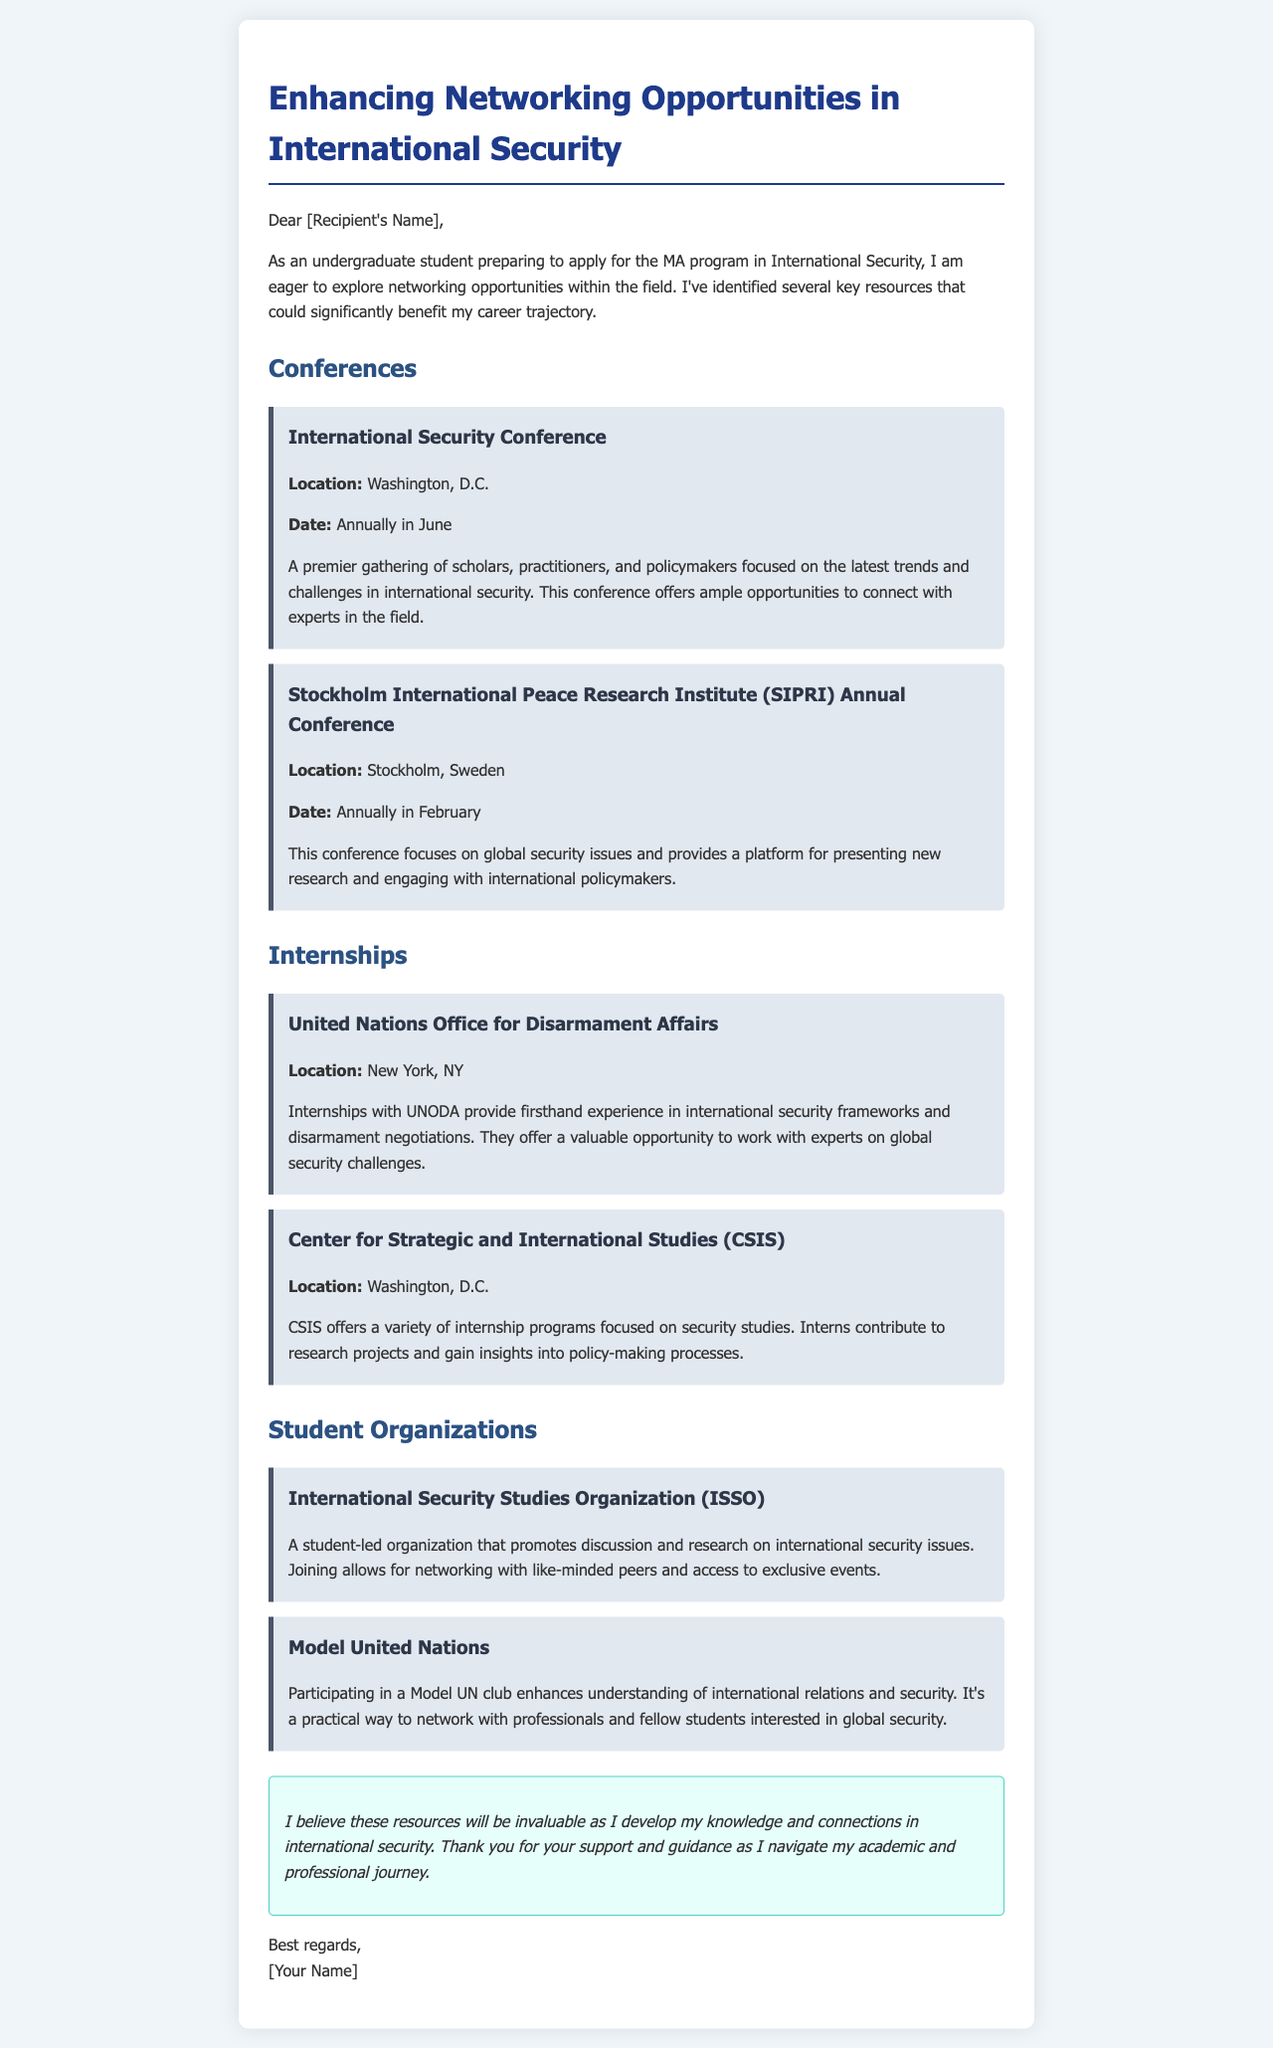what is the location of the International Security Conference? The location of the International Security Conference is mentioned in the document as Washington, D.C.
Answer: Washington, D.C what is the date of the SIPRI Annual Conference? The date for the SIPRI Annual Conference is provided as annually in February.
Answer: Annually in February where can internships be found at the United Nations? The document states that internships can be found at the United Nations Office for Disarmament Affairs.
Answer: United Nations Office for Disarmament Affairs what type of organization is the ISSO? The ISSO is described as a student-led organization in the document focused on international security issues.
Answer: Student-led organization what does participating in Model UN enhance? The document states that participating in Model UN enhances understanding of international relations and security.
Answer: Understanding of international relations and security how often is the International Security Conference held? The document indicates that the conference is held annually.
Answer: Annually what type of opportunities does the CSIS internship provide? The document specifies that CSIS internships provide insights into policy-making processes.
Answer: Insights into policy-making processes what is the focus of the SIPRI Annual Conference? The document highlights that the focus of the SIPRI Annual Conference is on global security issues.
Answer: Global security issues 